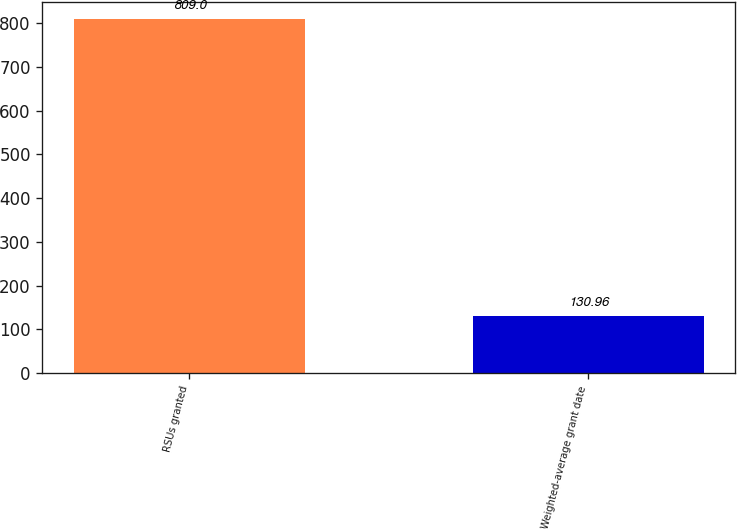Convert chart. <chart><loc_0><loc_0><loc_500><loc_500><bar_chart><fcel>RSUs granted<fcel>Weighted-average grant date<nl><fcel>809<fcel>130.96<nl></chart> 